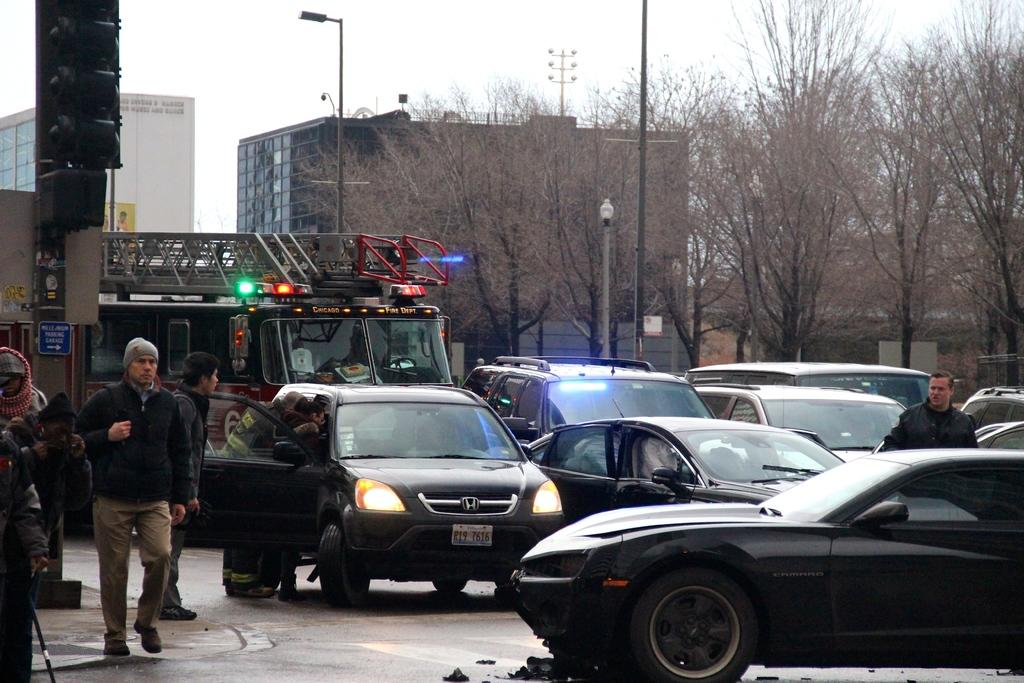What is the man in the image doing? There is a man walking on the road in the image. What else can be seen on the road in the image? There are other cars visible in the image. Are there any other people in the image besides the man walking? Yes, there is another man in the image. What can be seen in the background of the image? There is a vehicle, a tree, a pole, and the sky visible in the background of the image. What type of skirt is the minister wearing in the image? There is no minister or skirt present in the image. What is the minister using to connect the vehicle to the pole in the image? There is no minister, vehicle, or pole connected by a cord in the image. 